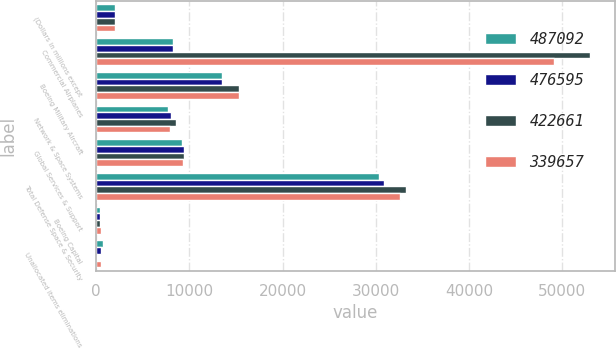Convert chart. <chart><loc_0><loc_0><loc_500><loc_500><stacked_bar_chart><ecel><fcel>(Dollars in millions except<fcel>Commercial Airplanes<fcel>Boeing Military Aircraft<fcel>Network & Space Systems<fcel>Global Services & Support<fcel>Total Defense Space & Security<fcel>Boeing Capital<fcel>Unallocated items eliminations<nl><fcel>487092<fcel>2015<fcel>8257.5<fcel>13482<fcel>7751<fcel>9155<fcel>30388<fcel>413<fcel>735<nl><fcel>476595<fcel>2014<fcel>8257.5<fcel>13500<fcel>8003<fcel>9378<fcel>30881<fcel>416<fcel>525<nl><fcel>422661<fcel>2013<fcel>52981<fcel>15275<fcel>8512<fcel>9410<fcel>33197<fcel>408<fcel>37<nl><fcel>339657<fcel>2012<fcel>49127<fcel>15373<fcel>7911<fcel>9323<fcel>32607<fcel>468<fcel>504<nl></chart> 